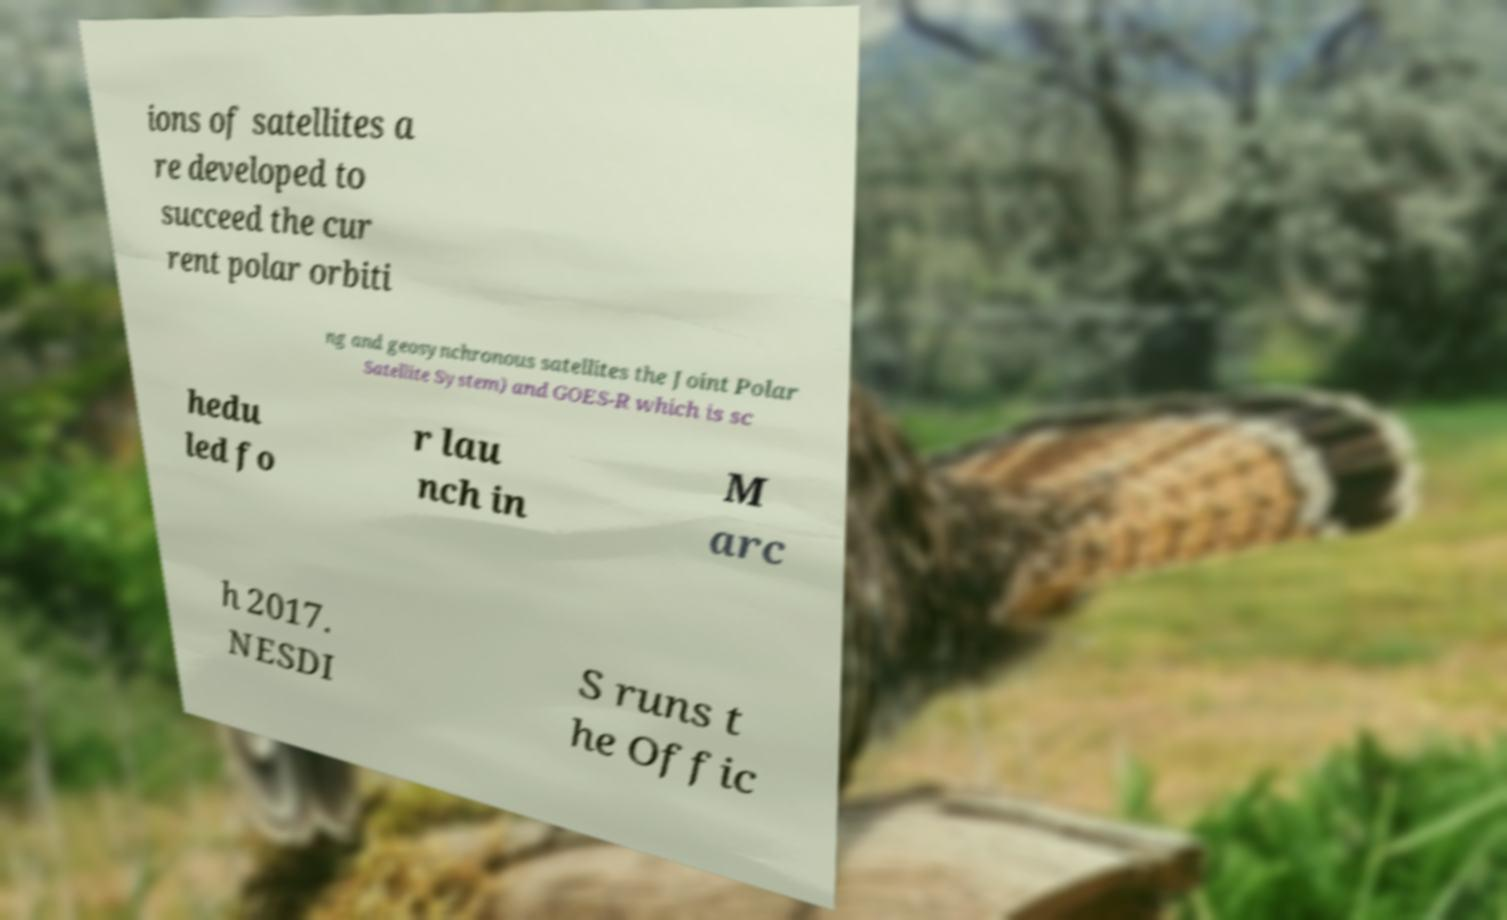I need the written content from this picture converted into text. Can you do that? ions of satellites a re developed to succeed the cur rent polar orbiti ng and geosynchronous satellites the Joint Polar Satellite System) and GOES-R which is sc hedu led fo r lau nch in M arc h 2017. NESDI S runs t he Offic 